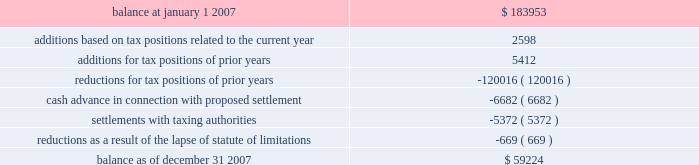American tower corporation and subsidiaries notes to consolidated financial statements 2014 ( continued ) company is currently unable to estimate the impact of the amount of such changes , if any , to previously recorded uncertain tax positions .
A reconciliation of the beginning and ending amount of unrecognized tax benefits for the year ending december 31 , 2007 is as follows ( in thousands ) : .
During the year ended december 31 , 2007 , the company recorded penalties and tax-related interest income of $ 2.5 million and interest income from tax refunds of $ 1.5 million for the year ended december 31 , 2007 .
As of december 31 , 2007 and january 1 , 2007 , the total unrecognized tax benefits included in other long-term liabilities in the consolidated balance sheets was $ 29.6 million and $ 34.3 million , respectively .
As of december 31 , 2007 and january 1 , 2007 , the total amount of accrued income tax-related interest and penalties included in other long-term liabilities in the consolidated balance sheets was $ 30.7 million and $ 33.2 million , respectively .
In the fourth quarter of 2007 , the company entered into a tax amnesty program with the mexican tax authority .
As of december 31 , 2007 , the company had met all of the administrative requirements of the program , which enabled the company to recognize certain tax benefits .
This was confirmed by the mexican tax authority on february 5 , 2008 .
These benefits include a reduction of uncertain tax benefits of $ 5.4 million along with penalties and interest of $ 12.5 million related to 2002 , all of which reduced income tax expense .
In connection with the above program , the company paid $ 6.7 million to the mexican tax authority as a settlement offer for other uncertain tax positions related to 2003 and 2004 .
This offer is currently under review by the mexican tax authority ; the company cannot yet determine the specific timing or the amount of any potential settlement .
During 2007 , the statute of limitations on certain unrecognized tax benefits lapsed , which resulted in a $ 0.7 million decrease in the liability for uncertain tax benefits , all of which reduced the income tax provision .
The company files numerous consolidated and separate income tax returns , including u.s .
Federal and state tax returns and foreign tax returns in mexico and brazil .
As a result of the company 2019s ability to carry forward federal and state net operating losses , the applicable tax years remain open to examination until three years after the applicable loss carryforwards have been used or expired .
However , the company has completed u.s .
Federal income tax examinations for tax years up to and including 2002 .
The company is currently undergoing u.s .
Federal income tax examinations for tax years 2004 and 2005 .
Additionally , it is subject to examinations in various u.s .
State jurisdictions for certain tax years , and is under examination in brazil for the 2001 through 2006 tax years and mexico for the 2002 tax year .
Sfas no .
109 , 201caccounting for income taxes , 201d requires that companies record a valuation allowance when it is 201cmore likely than not that some portion or all of the deferred tax assets will not be realized . 201d at december 31 , 2007 , the company has provided a valuation allowance of approximately $ 88.2 million , including approximately .
Without the statutes running in 2007 , what would the total be in thousands of the unrecognized tax benefits?\\n? 
Computations: (59224 + 669)
Answer: 59893.0. 